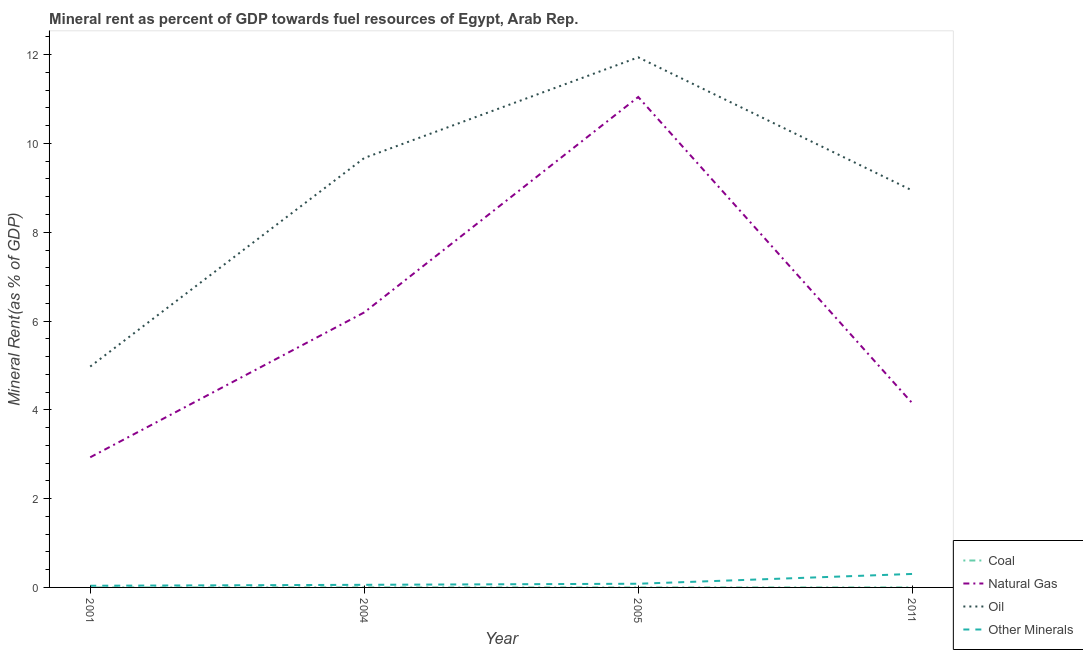How many different coloured lines are there?
Make the answer very short. 4. Does the line corresponding to oil rent intersect with the line corresponding to natural gas rent?
Keep it short and to the point. No. Is the number of lines equal to the number of legend labels?
Provide a succinct answer. Yes. What is the natural gas rent in 2005?
Provide a succinct answer. 11.05. Across all years, what is the maximum  rent of other minerals?
Offer a terse response. 0.3. Across all years, what is the minimum  rent of other minerals?
Offer a very short reply. 0.04. In which year was the  rent of other minerals minimum?
Your answer should be compact. 2001. What is the total coal rent in the graph?
Your answer should be compact. 0. What is the difference between the natural gas rent in 2004 and that in 2005?
Provide a succinct answer. -4.85. What is the difference between the  rent of other minerals in 2004 and the oil rent in 2001?
Ensure brevity in your answer.  -4.92. What is the average oil rent per year?
Give a very brief answer. 8.88. In the year 2011, what is the difference between the  rent of other minerals and natural gas rent?
Ensure brevity in your answer.  -3.85. In how many years, is the natural gas rent greater than 11.2 %?
Your answer should be very brief. 0. What is the ratio of the natural gas rent in 2001 to that in 2005?
Give a very brief answer. 0.27. What is the difference between the highest and the second highest natural gas rent?
Provide a succinct answer. 4.85. What is the difference between the highest and the lowest coal rent?
Your response must be concise. 0. In how many years, is the coal rent greater than the average coal rent taken over all years?
Offer a very short reply. 2. Is the sum of the natural gas rent in 2004 and 2005 greater than the maximum coal rent across all years?
Your answer should be very brief. Yes. Is the natural gas rent strictly less than the  rent of other minerals over the years?
Keep it short and to the point. No. How many years are there in the graph?
Give a very brief answer. 4. Are the values on the major ticks of Y-axis written in scientific E-notation?
Keep it short and to the point. No. Does the graph contain any zero values?
Your answer should be compact. No. Does the graph contain grids?
Offer a very short reply. No. How are the legend labels stacked?
Your answer should be very brief. Vertical. What is the title of the graph?
Make the answer very short. Mineral rent as percent of GDP towards fuel resources of Egypt, Arab Rep. What is the label or title of the Y-axis?
Your response must be concise. Mineral Rent(as % of GDP). What is the Mineral Rent(as % of GDP) in Coal in 2001?
Your answer should be very brief. 1.02739128441411e-6. What is the Mineral Rent(as % of GDP) of Natural Gas in 2001?
Offer a terse response. 2.93. What is the Mineral Rent(as % of GDP) in Oil in 2001?
Your answer should be very brief. 4.98. What is the Mineral Rent(as % of GDP) in Other Minerals in 2001?
Give a very brief answer. 0.04. What is the Mineral Rent(as % of GDP) of Coal in 2004?
Offer a very short reply. 0. What is the Mineral Rent(as % of GDP) of Natural Gas in 2004?
Offer a very short reply. 6.19. What is the Mineral Rent(as % of GDP) in Oil in 2004?
Give a very brief answer. 9.67. What is the Mineral Rent(as % of GDP) in Other Minerals in 2004?
Make the answer very short. 0.06. What is the Mineral Rent(as % of GDP) of Coal in 2005?
Provide a succinct answer. 0. What is the Mineral Rent(as % of GDP) of Natural Gas in 2005?
Your response must be concise. 11.05. What is the Mineral Rent(as % of GDP) in Oil in 2005?
Give a very brief answer. 11.94. What is the Mineral Rent(as % of GDP) of Other Minerals in 2005?
Ensure brevity in your answer.  0.08. What is the Mineral Rent(as % of GDP) in Coal in 2011?
Your answer should be compact. 0. What is the Mineral Rent(as % of GDP) of Natural Gas in 2011?
Your response must be concise. 4.15. What is the Mineral Rent(as % of GDP) in Oil in 2011?
Your answer should be compact. 8.94. What is the Mineral Rent(as % of GDP) in Other Minerals in 2011?
Provide a short and direct response. 0.3. Across all years, what is the maximum Mineral Rent(as % of GDP) in Coal?
Your answer should be very brief. 0. Across all years, what is the maximum Mineral Rent(as % of GDP) in Natural Gas?
Make the answer very short. 11.05. Across all years, what is the maximum Mineral Rent(as % of GDP) of Oil?
Offer a terse response. 11.94. Across all years, what is the maximum Mineral Rent(as % of GDP) in Other Minerals?
Give a very brief answer. 0.3. Across all years, what is the minimum Mineral Rent(as % of GDP) in Coal?
Your response must be concise. 1.02739128441411e-6. Across all years, what is the minimum Mineral Rent(as % of GDP) of Natural Gas?
Offer a terse response. 2.93. Across all years, what is the minimum Mineral Rent(as % of GDP) in Oil?
Make the answer very short. 4.98. Across all years, what is the minimum Mineral Rent(as % of GDP) in Other Minerals?
Keep it short and to the point. 0.04. What is the total Mineral Rent(as % of GDP) in Coal in the graph?
Your answer should be very brief. 0. What is the total Mineral Rent(as % of GDP) of Natural Gas in the graph?
Your answer should be compact. 24.32. What is the total Mineral Rent(as % of GDP) in Oil in the graph?
Your answer should be very brief. 35.53. What is the total Mineral Rent(as % of GDP) of Other Minerals in the graph?
Offer a very short reply. 0.48. What is the difference between the Mineral Rent(as % of GDP) of Coal in 2001 and that in 2004?
Give a very brief answer. -0. What is the difference between the Mineral Rent(as % of GDP) of Natural Gas in 2001 and that in 2004?
Ensure brevity in your answer.  -3.26. What is the difference between the Mineral Rent(as % of GDP) in Oil in 2001 and that in 2004?
Provide a succinct answer. -4.7. What is the difference between the Mineral Rent(as % of GDP) in Other Minerals in 2001 and that in 2004?
Offer a very short reply. -0.02. What is the difference between the Mineral Rent(as % of GDP) in Coal in 2001 and that in 2005?
Your answer should be very brief. -0. What is the difference between the Mineral Rent(as % of GDP) in Natural Gas in 2001 and that in 2005?
Make the answer very short. -8.12. What is the difference between the Mineral Rent(as % of GDP) of Oil in 2001 and that in 2005?
Provide a short and direct response. -6.96. What is the difference between the Mineral Rent(as % of GDP) of Other Minerals in 2001 and that in 2005?
Offer a terse response. -0.05. What is the difference between the Mineral Rent(as % of GDP) of Coal in 2001 and that in 2011?
Your answer should be very brief. -0. What is the difference between the Mineral Rent(as % of GDP) of Natural Gas in 2001 and that in 2011?
Keep it short and to the point. -1.22. What is the difference between the Mineral Rent(as % of GDP) in Oil in 2001 and that in 2011?
Ensure brevity in your answer.  -3.97. What is the difference between the Mineral Rent(as % of GDP) in Other Minerals in 2001 and that in 2011?
Ensure brevity in your answer.  -0.27. What is the difference between the Mineral Rent(as % of GDP) of Natural Gas in 2004 and that in 2005?
Your answer should be very brief. -4.85. What is the difference between the Mineral Rent(as % of GDP) in Oil in 2004 and that in 2005?
Provide a succinct answer. -2.27. What is the difference between the Mineral Rent(as % of GDP) of Other Minerals in 2004 and that in 2005?
Provide a short and direct response. -0.02. What is the difference between the Mineral Rent(as % of GDP) in Coal in 2004 and that in 2011?
Provide a short and direct response. 0. What is the difference between the Mineral Rent(as % of GDP) of Natural Gas in 2004 and that in 2011?
Provide a succinct answer. 2.04. What is the difference between the Mineral Rent(as % of GDP) in Oil in 2004 and that in 2011?
Make the answer very short. 0.73. What is the difference between the Mineral Rent(as % of GDP) in Other Minerals in 2004 and that in 2011?
Provide a succinct answer. -0.24. What is the difference between the Mineral Rent(as % of GDP) in Coal in 2005 and that in 2011?
Your answer should be compact. -0. What is the difference between the Mineral Rent(as % of GDP) of Natural Gas in 2005 and that in 2011?
Your response must be concise. 6.9. What is the difference between the Mineral Rent(as % of GDP) in Oil in 2005 and that in 2011?
Your answer should be compact. 3. What is the difference between the Mineral Rent(as % of GDP) in Other Minerals in 2005 and that in 2011?
Provide a short and direct response. -0.22. What is the difference between the Mineral Rent(as % of GDP) in Coal in 2001 and the Mineral Rent(as % of GDP) in Natural Gas in 2004?
Offer a very short reply. -6.19. What is the difference between the Mineral Rent(as % of GDP) of Coal in 2001 and the Mineral Rent(as % of GDP) of Oil in 2004?
Give a very brief answer. -9.67. What is the difference between the Mineral Rent(as % of GDP) of Coal in 2001 and the Mineral Rent(as % of GDP) of Other Minerals in 2004?
Your answer should be very brief. -0.06. What is the difference between the Mineral Rent(as % of GDP) in Natural Gas in 2001 and the Mineral Rent(as % of GDP) in Oil in 2004?
Give a very brief answer. -6.74. What is the difference between the Mineral Rent(as % of GDP) of Natural Gas in 2001 and the Mineral Rent(as % of GDP) of Other Minerals in 2004?
Make the answer very short. 2.87. What is the difference between the Mineral Rent(as % of GDP) of Oil in 2001 and the Mineral Rent(as % of GDP) of Other Minerals in 2004?
Ensure brevity in your answer.  4.92. What is the difference between the Mineral Rent(as % of GDP) in Coal in 2001 and the Mineral Rent(as % of GDP) in Natural Gas in 2005?
Give a very brief answer. -11.05. What is the difference between the Mineral Rent(as % of GDP) in Coal in 2001 and the Mineral Rent(as % of GDP) in Oil in 2005?
Make the answer very short. -11.94. What is the difference between the Mineral Rent(as % of GDP) of Coal in 2001 and the Mineral Rent(as % of GDP) of Other Minerals in 2005?
Offer a terse response. -0.08. What is the difference between the Mineral Rent(as % of GDP) in Natural Gas in 2001 and the Mineral Rent(as % of GDP) in Oil in 2005?
Keep it short and to the point. -9.01. What is the difference between the Mineral Rent(as % of GDP) of Natural Gas in 2001 and the Mineral Rent(as % of GDP) of Other Minerals in 2005?
Offer a very short reply. 2.85. What is the difference between the Mineral Rent(as % of GDP) in Oil in 2001 and the Mineral Rent(as % of GDP) in Other Minerals in 2005?
Your answer should be compact. 4.89. What is the difference between the Mineral Rent(as % of GDP) in Coal in 2001 and the Mineral Rent(as % of GDP) in Natural Gas in 2011?
Make the answer very short. -4.15. What is the difference between the Mineral Rent(as % of GDP) of Coal in 2001 and the Mineral Rent(as % of GDP) of Oil in 2011?
Make the answer very short. -8.94. What is the difference between the Mineral Rent(as % of GDP) of Coal in 2001 and the Mineral Rent(as % of GDP) of Other Minerals in 2011?
Your answer should be compact. -0.3. What is the difference between the Mineral Rent(as % of GDP) of Natural Gas in 2001 and the Mineral Rent(as % of GDP) of Oil in 2011?
Keep it short and to the point. -6.01. What is the difference between the Mineral Rent(as % of GDP) of Natural Gas in 2001 and the Mineral Rent(as % of GDP) of Other Minerals in 2011?
Give a very brief answer. 2.63. What is the difference between the Mineral Rent(as % of GDP) in Oil in 2001 and the Mineral Rent(as % of GDP) in Other Minerals in 2011?
Keep it short and to the point. 4.67. What is the difference between the Mineral Rent(as % of GDP) in Coal in 2004 and the Mineral Rent(as % of GDP) in Natural Gas in 2005?
Ensure brevity in your answer.  -11.05. What is the difference between the Mineral Rent(as % of GDP) in Coal in 2004 and the Mineral Rent(as % of GDP) in Oil in 2005?
Your response must be concise. -11.94. What is the difference between the Mineral Rent(as % of GDP) of Coal in 2004 and the Mineral Rent(as % of GDP) of Other Minerals in 2005?
Provide a succinct answer. -0.08. What is the difference between the Mineral Rent(as % of GDP) of Natural Gas in 2004 and the Mineral Rent(as % of GDP) of Oil in 2005?
Keep it short and to the point. -5.75. What is the difference between the Mineral Rent(as % of GDP) of Natural Gas in 2004 and the Mineral Rent(as % of GDP) of Other Minerals in 2005?
Give a very brief answer. 6.11. What is the difference between the Mineral Rent(as % of GDP) in Oil in 2004 and the Mineral Rent(as % of GDP) in Other Minerals in 2005?
Give a very brief answer. 9.59. What is the difference between the Mineral Rent(as % of GDP) in Coal in 2004 and the Mineral Rent(as % of GDP) in Natural Gas in 2011?
Your answer should be very brief. -4.15. What is the difference between the Mineral Rent(as % of GDP) in Coal in 2004 and the Mineral Rent(as % of GDP) in Oil in 2011?
Provide a short and direct response. -8.94. What is the difference between the Mineral Rent(as % of GDP) of Coal in 2004 and the Mineral Rent(as % of GDP) of Other Minerals in 2011?
Make the answer very short. -0.3. What is the difference between the Mineral Rent(as % of GDP) of Natural Gas in 2004 and the Mineral Rent(as % of GDP) of Oil in 2011?
Give a very brief answer. -2.75. What is the difference between the Mineral Rent(as % of GDP) of Natural Gas in 2004 and the Mineral Rent(as % of GDP) of Other Minerals in 2011?
Ensure brevity in your answer.  5.89. What is the difference between the Mineral Rent(as % of GDP) in Oil in 2004 and the Mineral Rent(as % of GDP) in Other Minerals in 2011?
Your response must be concise. 9.37. What is the difference between the Mineral Rent(as % of GDP) of Coal in 2005 and the Mineral Rent(as % of GDP) of Natural Gas in 2011?
Offer a very short reply. -4.15. What is the difference between the Mineral Rent(as % of GDP) of Coal in 2005 and the Mineral Rent(as % of GDP) of Oil in 2011?
Provide a short and direct response. -8.94. What is the difference between the Mineral Rent(as % of GDP) of Coal in 2005 and the Mineral Rent(as % of GDP) of Other Minerals in 2011?
Your answer should be very brief. -0.3. What is the difference between the Mineral Rent(as % of GDP) of Natural Gas in 2005 and the Mineral Rent(as % of GDP) of Oil in 2011?
Provide a short and direct response. 2.11. What is the difference between the Mineral Rent(as % of GDP) in Natural Gas in 2005 and the Mineral Rent(as % of GDP) in Other Minerals in 2011?
Your answer should be compact. 10.74. What is the difference between the Mineral Rent(as % of GDP) in Oil in 2005 and the Mineral Rent(as % of GDP) in Other Minerals in 2011?
Ensure brevity in your answer.  11.64. What is the average Mineral Rent(as % of GDP) of Natural Gas per year?
Make the answer very short. 6.08. What is the average Mineral Rent(as % of GDP) of Oil per year?
Offer a terse response. 8.88. What is the average Mineral Rent(as % of GDP) in Other Minerals per year?
Your answer should be very brief. 0.12. In the year 2001, what is the difference between the Mineral Rent(as % of GDP) of Coal and Mineral Rent(as % of GDP) of Natural Gas?
Make the answer very short. -2.93. In the year 2001, what is the difference between the Mineral Rent(as % of GDP) in Coal and Mineral Rent(as % of GDP) in Oil?
Your response must be concise. -4.98. In the year 2001, what is the difference between the Mineral Rent(as % of GDP) of Coal and Mineral Rent(as % of GDP) of Other Minerals?
Keep it short and to the point. -0.04. In the year 2001, what is the difference between the Mineral Rent(as % of GDP) of Natural Gas and Mineral Rent(as % of GDP) of Oil?
Give a very brief answer. -2.04. In the year 2001, what is the difference between the Mineral Rent(as % of GDP) in Natural Gas and Mineral Rent(as % of GDP) in Other Minerals?
Your answer should be very brief. 2.89. In the year 2001, what is the difference between the Mineral Rent(as % of GDP) of Oil and Mineral Rent(as % of GDP) of Other Minerals?
Keep it short and to the point. 4.94. In the year 2004, what is the difference between the Mineral Rent(as % of GDP) of Coal and Mineral Rent(as % of GDP) of Natural Gas?
Provide a short and direct response. -6.19. In the year 2004, what is the difference between the Mineral Rent(as % of GDP) in Coal and Mineral Rent(as % of GDP) in Oil?
Offer a terse response. -9.67. In the year 2004, what is the difference between the Mineral Rent(as % of GDP) in Coal and Mineral Rent(as % of GDP) in Other Minerals?
Your response must be concise. -0.06. In the year 2004, what is the difference between the Mineral Rent(as % of GDP) in Natural Gas and Mineral Rent(as % of GDP) in Oil?
Offer a terse response. -3.48. In the year 2004, what is the difference between the Mineral Rent(as % of GDP) of Natural Gas and Mineral Rent(as % of GDP) of Other Minerals?
Provide a succinct answer. 6.14. In the year 2004, what is the difference between the Mineral Rent(as % of GDP) in Oil and Mineral Rent(as % of GDP) in Other Minerals?
Provide a short and direct response. 9.61. In the year 2005, what is the difference between the Mineral Rent(as % of GDP) of Coal and Mineral Rent(as % of GDP) of Natural Gas?
Make the answer very short. -11.05. In the year 2005, what is the difference between the Mineral Rent(as % of GDP) in Coal and Mineral Rent(as % of GDP) in Oil?
Provide a short and direct response. -11.94. In the year 2005, what is the difference between the Mineral Rent(as % of GDP) in Coal and Mineral Rent(as % of GDP) in Other Minerals?
Offer a terse response. -0.08. In the year 2005, what is the difference between the Mineral Rent(as % of GDP) of Natural Gas and Mineral Rent(as % of GDP) of Oil?
Make the answer very short. -0.89. In the year 2005, what is the difference between the Mineral Rent(as % of GDP) of Natural Gas and Mineral Rent(as % of GDP) of Other Minerals?
Give a very brief answer. 10.96. In the year 2005, what is the difference between the Mineral Rent(as % of GDP) in Oil and Mineral Rent(as % of GDP) in Other Minerals?
Your answer should be compact. 11.86. In the year 2011, what is the difference between the Mineral Rent(as % of GDP) in Coal and Mineral Rent(as % of GDP) in Natural Gas?
Offer a terse response. -4.15. In the year 2011, what is the difference between the Mineral Rent(as % of GDP) in Coal and Mineral Rent(as % of GDP) in Oil?
Offer a terse response. -8.94. In the year 2011, what is the difference between the Mineral Rent(as % of GDP) in Coal and Mineral Rent(as % of GDP) in Other Minerals?
Your answer should be compact. -0.3. In the year 2011, what is the difference between the Mineral Rent(as % of GDP) in Natural Gas and Mineral Rent(as % of GDP) in Oil?
Make the answer very short. -4.79. In the year 2011, what is the difference between the Mineral Rent(as % of GDP) of Natural Gas and Mineral Rent(as % of GDP) of Other Minerals?
Provide a short and direct response. 3.85. In the year 2011, what is the difference between the Mineral Rent(as % of GDP) of Oil and Mineral Rent(as % of GDP) of Other Minerals?
Your response must be concise. 8.64. What is the ratio of the Mineral Rent(as % of GDP) in Coal in 2001 to that in 2004?
Give a very brief answer. 0. What is the ratio of the Mineral Rent(as % of GDP) of Natural Gas in 2001 to that in 2004?
Keep it short and to the point. 0.47. What is the ratio of the Mineral Rent(as % of GDP) in Oil in 2001 to that in 2004?
Offer a very short reply. 0.51. What is the ratio of the Mineral Rent(as % of GDP) in Other Minerals in 2001 to that in 2004?
Offer a terse response. 0.64. What is the ratio of the Mineral Rent(as % of GDP) in Coal in 2001 to that in 2005?
Your answer should be very brief. 0. What is the ratio of the Mineral Rent(as % of GDP) of Natural Gas in 2001 to that in 2005?
Provide a succinct answer. 0.27. What is the ratio of the Mineral Rent(as % of GDP) in Oil in 2001 to that in 2005?
Offer a very short reply. 0.42. What is the ratio of the Mineral Rent(as % of GDP) of Other Minerals in 2001 to that in 2005?
Provide a short and direct response. 0.45. What is the ratio of the Mineral Rent(as % of GDP) of Coal in 2001 to that in 2011?
Keep it short and to the point. 0. What is the ratio of the Mineral Rent(as % of GDP) of Natural Gas in 2001 to that in 2011?
Keep it short and to the point. 0.71. What is the ratio of the Mineral Rent(as % of GDP) in Oil in 2001 to that in 2011?
Ensure brevity in your answer.  0.56. What is the ratio of the Mineral Rent(as % of GDP) in Other Minerals in 2001 to that in 2011?
Provide a short and direct response. 0.12. What is the ratio of the Mineral Rent(as % of GDP) of Coal in 2004 to that in 2005?
Offer a terse response. 2.83. What is the ratio of the Mineral Rent(as % of GDP) in Natural Gas in 2004 to that in 2005?
Provide a succinct answer. 0.56. What is the ratio of the Mineral Rent(as % of GDP) of Oil in 2004 to that in 2005?
Keep it short and to the point. 0.81. What is the ratio of the Mineral Rent(as % of GDP) in Other Minerals in 2004 to that in 2005?
Give a very brief answer. 0.71. What is the ratio of the Mineral Rent(as % of GDP) in Coal in 2004 to that in 2011?
Offer a very short reply. 1.13. What is the ratio of the Mineral Rent(as % of GDP) of Natural Gas in 2004 to that in 2011?
Provide a short and direct response. 1.49. What is the ratio of the Mineral Rent(as % of GDP) of Oil in 2004 to that in 2011?
Provide a short and direct response. 1.08. What is the ratio of the Mineral Rent(as % of GDP) of Other Minerals in 2004 to that in 2011?
Offer a very short reply. 0.19. What is the ratio of the Mineral Rent(as % of GDP) of Coal in 2005 to that in 2011?
Ensure brevity in your answer.  0.4. What is the ratio of the Mineral Rent(as % of GDP) of Natural Gas in 2005 to that in 2011?
Keep it short and to the point. 2.66. What is the ratio of the Mineral Rent(as % of GDP) of Oil in 2005 to that in 2011?
Make the answer very short. 1.34. What is the ratio of the Mineral Rent(as % of GDP) in Other Minerals in 2005 to that in 2011?
Offer a terse response. 0.27. What is the difference between the highest and the second highest Mineral Rent(as % of GDP) in Coal?
Offer a very short reply. 0. What is the difference between the highest and the second highest Mineral Rent(as % of GDP) of Natural Gas?
Offer a very short reply. 4.85. What is the difference between the highest and the second highest Mineral Rent(as % of GDP) in Oil?
Your response must be concise. 2.27. What is the difference between the highest and the second highest Mineral Rent(as % of GDP) of Other Minerals?
Offer a terse response. 0.22. What is the difference between the highest and the lowest Mineral Rent(as % of GDP) of Coal?
Keep it short and to the point. 0. What is the difference between the highest and the lowest Mineral Rent(as % of GDP) of Natural Gas?
Make the answer very short. 8.12. What is the difference between the highest and the lowest Mineral Rent(as % of GDP) in Oil?
Offer a terse response. 6.96. What is the difference between the highest and the lowest Mineral Rent(as % of GDP) of Other Minerals?
Provide a succinct answer. 0.27. 